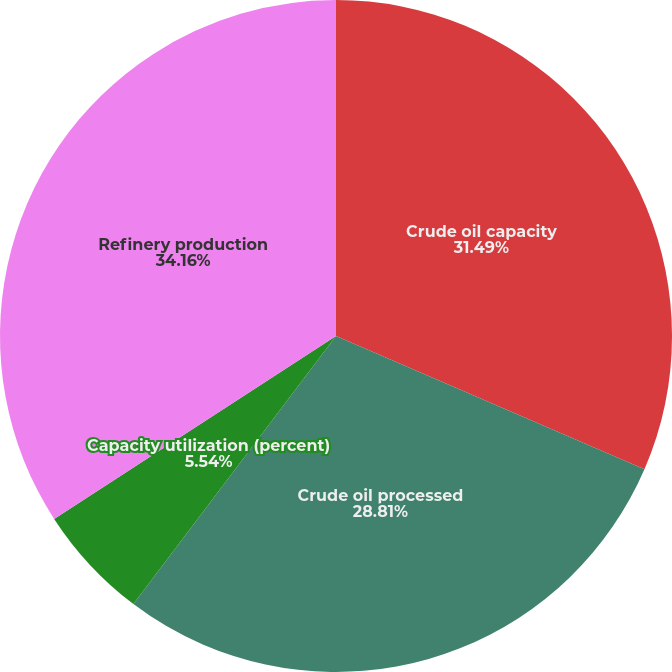Convert chart to OTSL. <chart><loc_0><loc_0><loc_500><loc_500><pie_chart><fcel>Crude oil capacity<fcel>Crude oil processed<fcel>Capacity utilization (percent)<fcel>Refinery production<nl><fcel>31.49%<fcel>28.81%<fcel>5.54%<fcel>34.16%<nl></chart> 